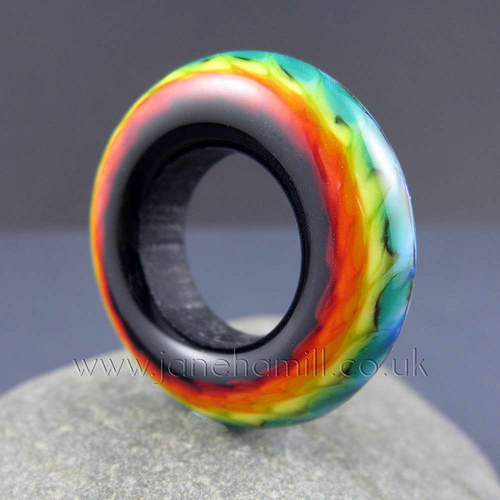<image>
Is the fire ball on the feather pillow? Yes. Looking at the image, I can see the fire ball is positioned on top of the feather pillow, with the feather pillow providing support. 